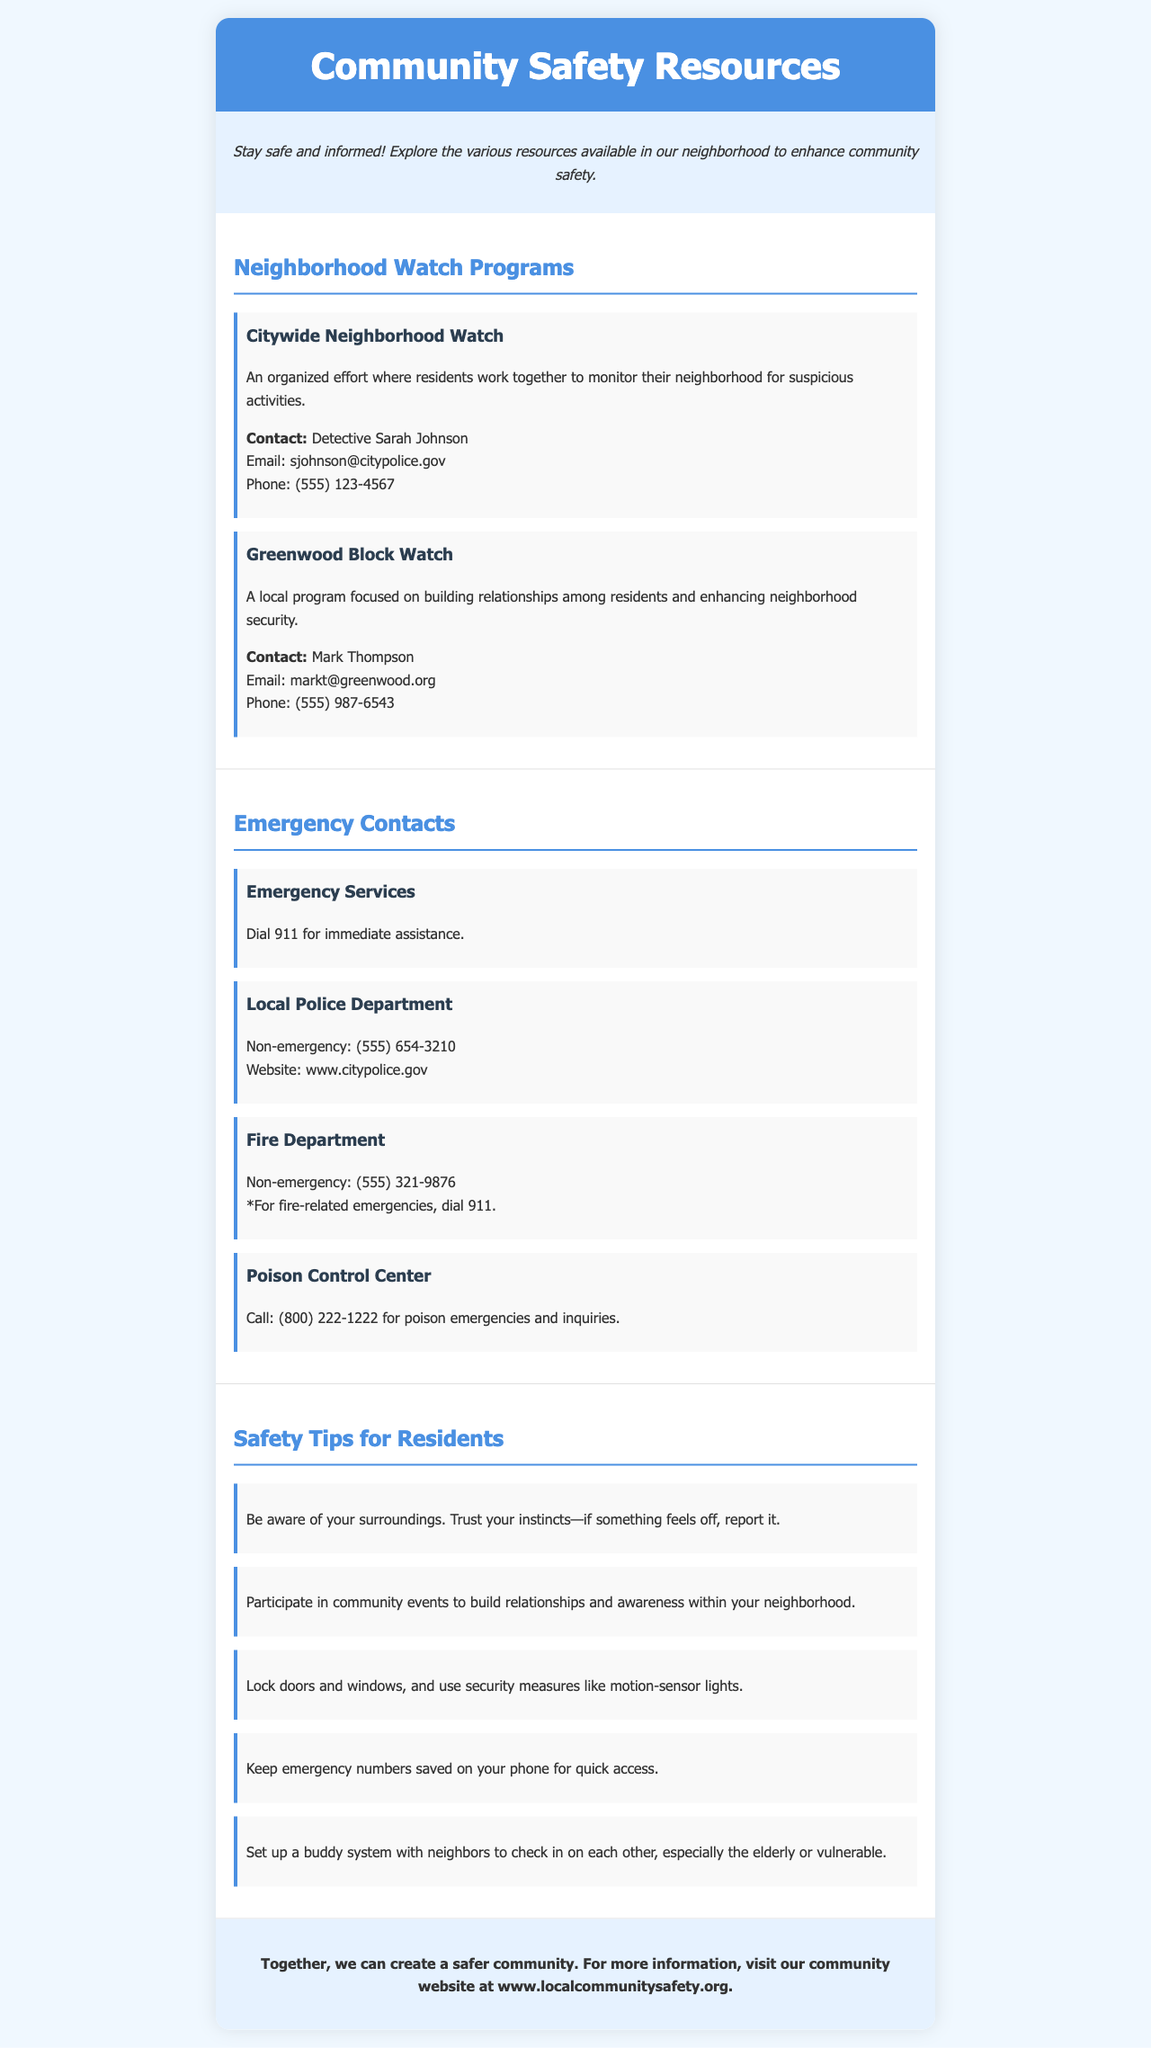What is the title of the brochure? The title is prominently displayed at the top of the document, indicating the focus on community safety resources.
Answer: Community Safety Resources Who can be contacted for the Citywide Neighborhood Watch? The contact information is listed under the respective neighborhood watch program, including the person’s name, email, and phone.
Answer: Detective Sarah Johnson What is the non-emergency number for the Local Police Department? The document contains specific contact information for local emergency services, including non-emergency lines.
Answer: (555) 654-3210 How many safety tips are provided for residents? The document lists several key safety recommendations for the community; counting those tips gives the answer.
Answer: 5 What is one safety tip mentioned in the brochure? The document lists multiple tips, providing various recommendations for residents' safety, highlighting practical steps to follow.
Answer: Be aware of your surroundings What is the purpose of the Greenwood Block Watch program? The description of the program provides insight into its goals, outlining its primary focus on community relationships and safety.
Answer: Building relationships among residents What should you dial for immediate assistance? Emergency contact information is clearly stated in the document; this specific action is emphasized in the emergency contacts section.
Answer: 911 What is the website for the local community safety information? A closing statement directs residents to a specific online resource for further details and assistance, concluding the brochure.
Answer: www.localcommunitysafety.org 